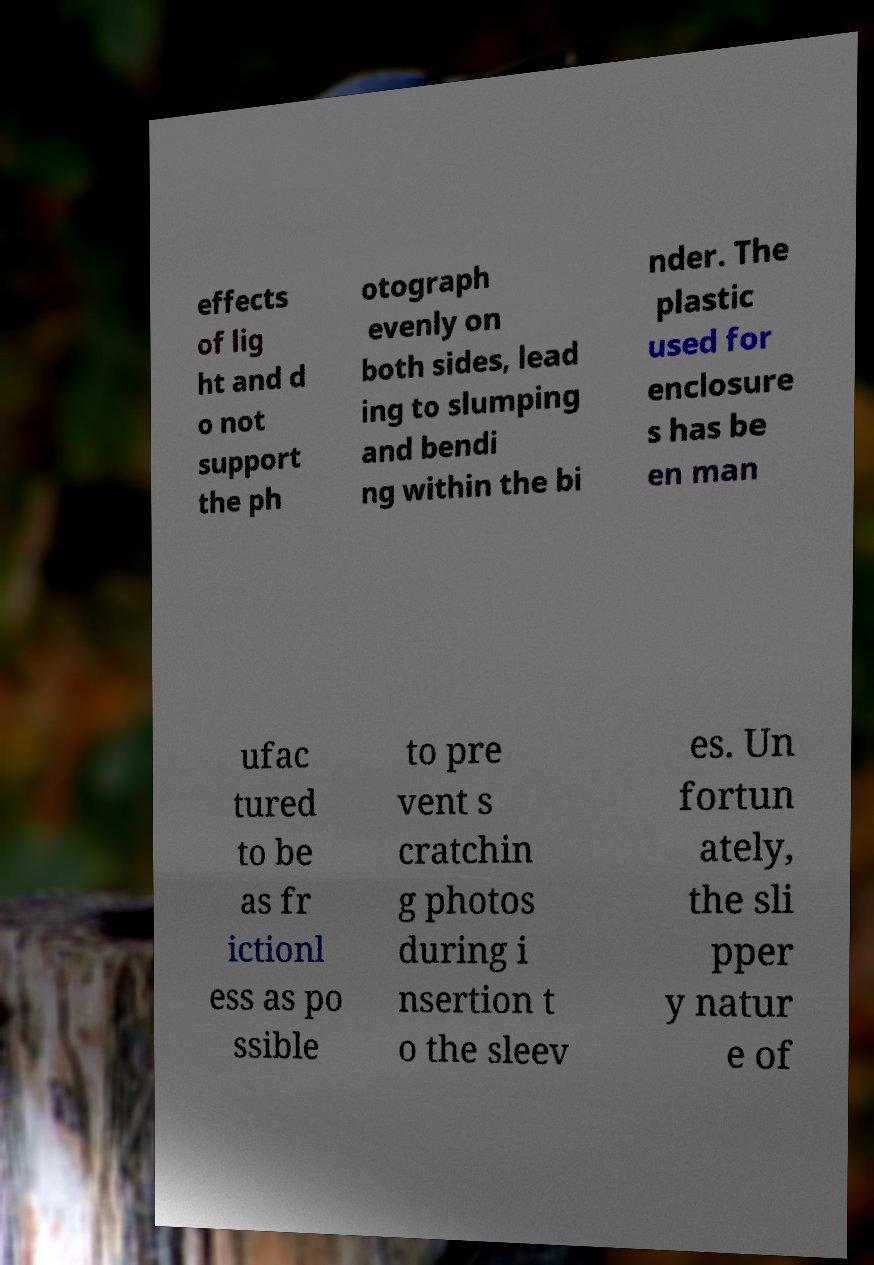Please read and relay the text visible in this image. What does it say? effects of lig ht and d o not support the ph otograph evenly on both sides, lead ing to slumping and bendi ng within the bi nder. The plastic used for enclosure s has be en man ufac tured to be as fr ictionl ess as po ssible to pre vent s cratchin g photos during i nsertion t o the sleev es. Un fortun ately, the sli pper y natur e of 